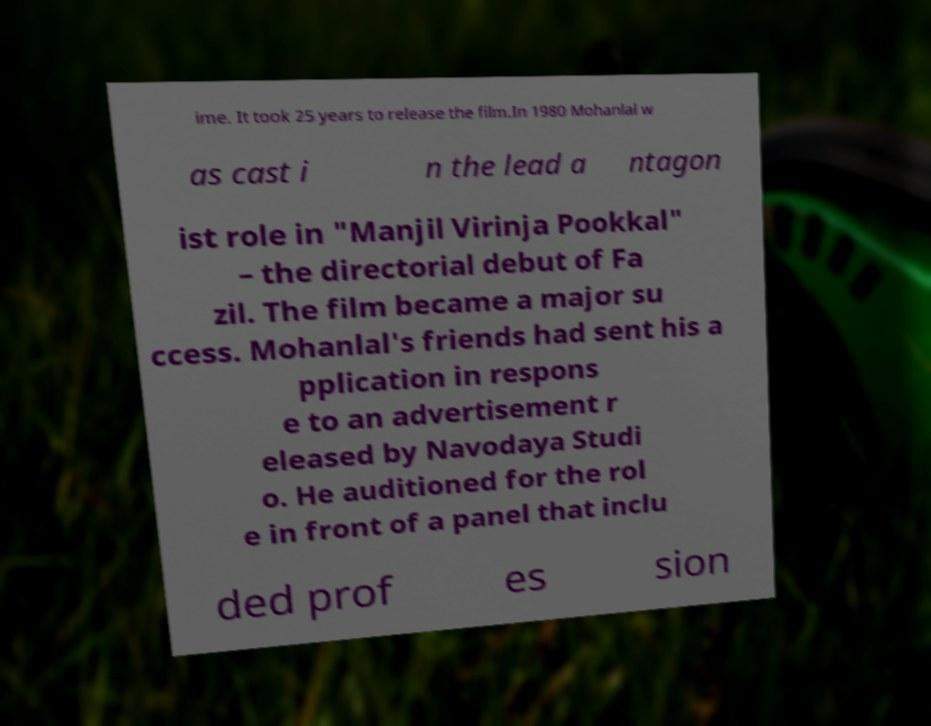Please identify and transcribe the text found in this image. ime. It took 25 years to release the film.In 1980 Mohanlal w as cast i n the lead a ntagon ist role in "Manjil Virinja Pookkal" – the directorial debut of Fa zil. The film became a major su ccess. Mohanlal's friends had sent his a pplication in respons e to an advertisement r eleased by Navodaya Studi o. He auditioned for the rol e in front of a panel that inclu ded prof es sion 